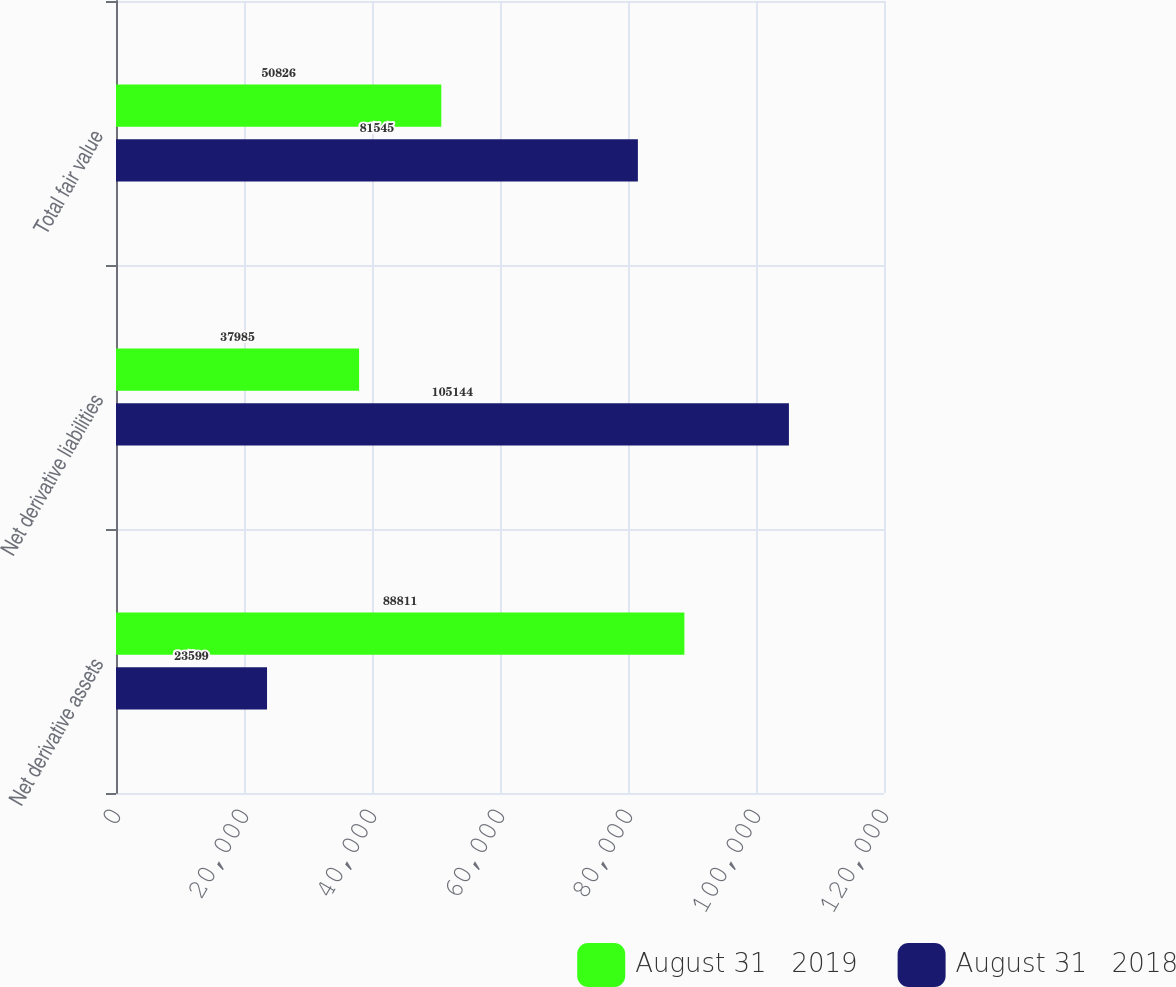<chart> <loc_0><loc_0><loc_500><loc_500><stacked_bar_chart><ecel><fcel>Net derivative assets<fcel>Net derivative liabilities<fcel>Total fair value<nl><fcel>August 31   2019<fcel>88811<fcel>37985<fcel>50826<nl><fcel>August 31   2018<fcel>23599<fcel>105144<fcel>81545<nl></chart> 